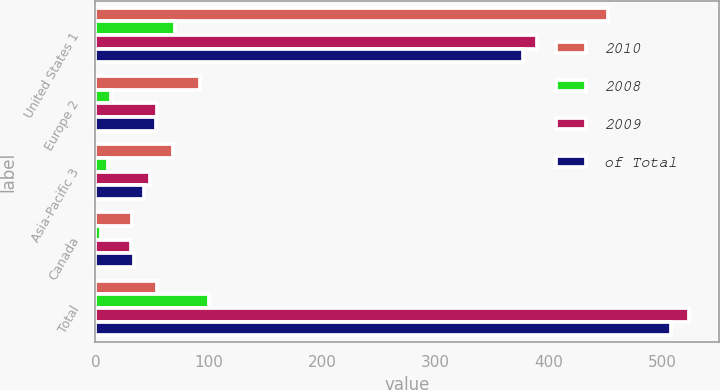Convert chart to OTSL. <chart><loc_0><loc_0><loc_500><loc_500><stacked_bar_chart><ecel><fcel>United States 1<fcel>Europe 2<fcel>Asia-Pacific 3<fcel>Canada<fcel>Total<nl><fcel>2010<fcel>451.7<fcel>92.2<fcel>68.4<fcel>32.6<fcel>54.7<nl><fcel>2008<fcel>70<fcel>14<fcel>11<fcel>5<fcel>100<nl><fcel>2009<fcel>389.3<fcel>54.7<fcel>48.3<fcel>31.1<fcel>523.4<nl><fcel>of Total<fcel>376.6<fcel>53.6<fcel>42.9<fcel>34.2<fcel>507.3<nl></chart> 